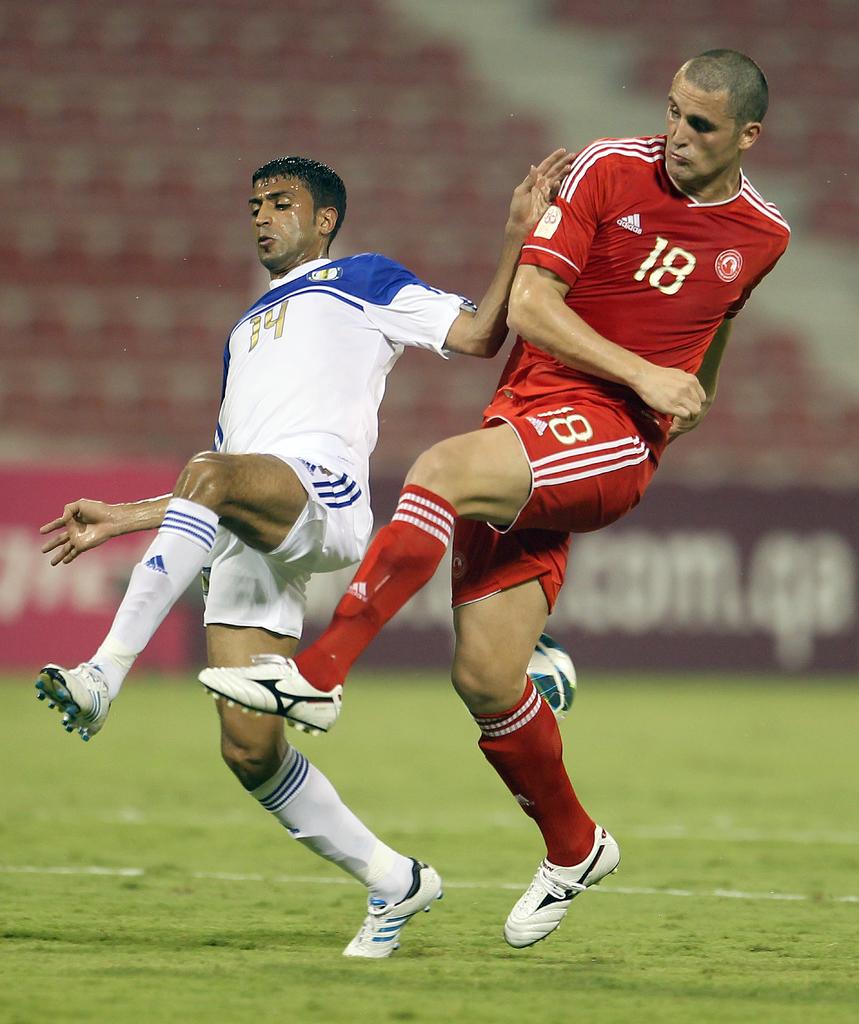Which number is the player in red?
Keep it short and to the point. 18. What number is the player in white?
Your response must be concise. 14. 